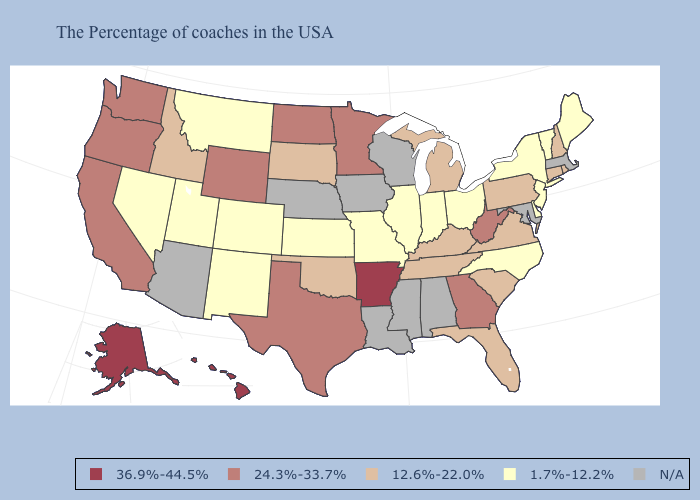Among the states that border Tennessee , does Missouri have the lowest value?
Answer briefly. Yes. Name the states that have a value in the range 1.7%-12.2%?
Write a very short answer. Maine, Vermont, New York, New Jersey, Delaware, North Carolina, Ohio, Indiana, Illinois, Missouri, Kansas, Colorado, New Mexico, Utah, Montana, Nevada. Does New Hampshire have the lowest value in the Northeast?
Answer briefly. No. What is the value of Indiana?
Give a very brief answer. 1.7%-12.2%. Does the map have missing data?
Short answer required. Yes. Name the states that have a value in the range 12.6%-22.0%?
Short answer required. Rhode Island, New Hampshire, Connecticut, Pennsylvania, Virginia, South Carolina, Florida, Michigan, Kentucky, Tennessee, Oklahoma, South Dakota, Idaho. Name the states that have a value in the range 1.7%-12.2%?
Give a very brief answer. Maine, Vermont, New York, New Jersey, Delaware, North Carolina, Ohio, Indiana, Illinois, Missouri, Kansas, Colorado, New Mexico, Utah, Montana, Nevada. Name the states that have a value in the range 24.3%-33.7%?
Give a very brief answer. West Virginia, Georgia, Minnesota, Texas, North Dakota, Wyoming, California, Washington, Oregon. What is the value of Alaska?
Short answer required. 36.9%-44.5%. Does the first symbol in the legend represent the smallest category?
Answer briefly. No. What is the highest value in states that border Tennessee?
Concise answer only. 36.9%-44.5%. What is the lowest value in the West?
Quick response, please. 1.7%-12.2%. Name the states that have a value in the range 12.6%-22.0%?
Answer briefly. Rhode Island, New Hampshire, Connecticut, Pennsylvania, Virginia, South Carolina, Florida, Michigan, Kentucky, Tennessee, Oklahoma, South Dakota, Idaho. 